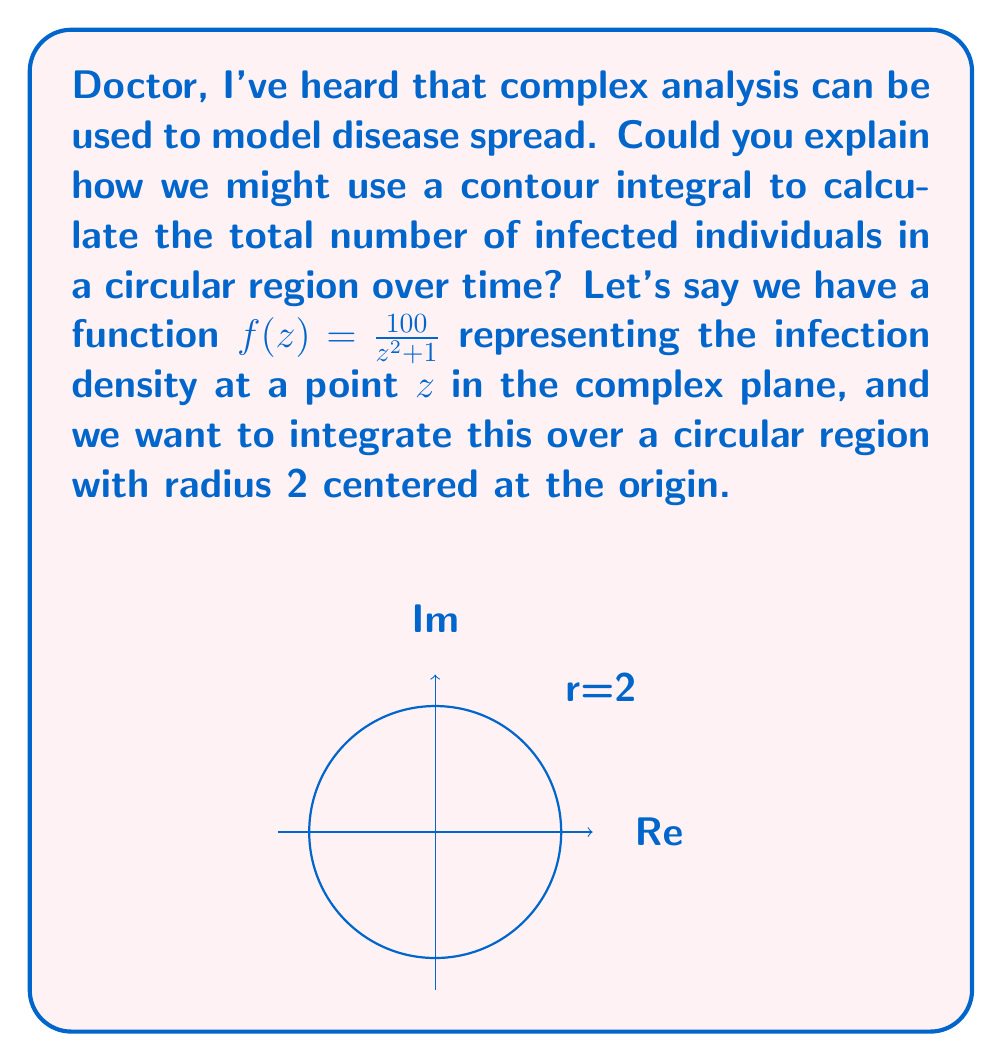Teach me how to tackle this problem. Certainly! Let's approach this step-by-step:

1) To find the total number of infected individuals, we need to integrate the density function over the given region. In complex analysis, this is done using a contour integral.

2) The contour in this case is a circle with radius 2 centered at the origin. We can parameterize this circle as $z = 2e^{i\theta}$, where $0 \leq \theta \leq 2\pi$.

3) The contour integral we need to evaluate is:

   $$\oint_C f(z) dz = \oint_C \frac{100}{z^2 + 1} dz$$

4) To evaluate this, we'll use the residue theorem, which states:

   $$\oint_C f(z) dz = 2\pi i \sum \text{Res}(f, a_k)$$

   where $a_k$ are the poles of $f(z)$ inside the contour.

5) The poles of $f(z)$ are at $z = \pm i$. Only $z = i$ is inside our contour.

6) To find the residue at $z = i$, we use:

   $$\text{Res}(f, i) = \lim_{z \to i} (z-i)\frac{100}{z^2 + 1}$$

7) Simplifying:
   
   $$\text{Res}(f, i) = \lim_{z \to i} \frac{100(z-i)}{(z+i)(z-i)} = \frac{100}{2i} = -50i$$

8) Applying the residue theorem:

   $$\oint_C \frac{100}{z^2 + 1} dz = 2\pi i (-50i) = 100\pi$$

This result represents the total number of infected individuals in the circular region.
Answer: $100\pi$ infected individuals 